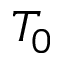Convert formula to latex. <formula><loc_0><loc_0><loc_500><loc_500>T _ { 0 }</formula> 